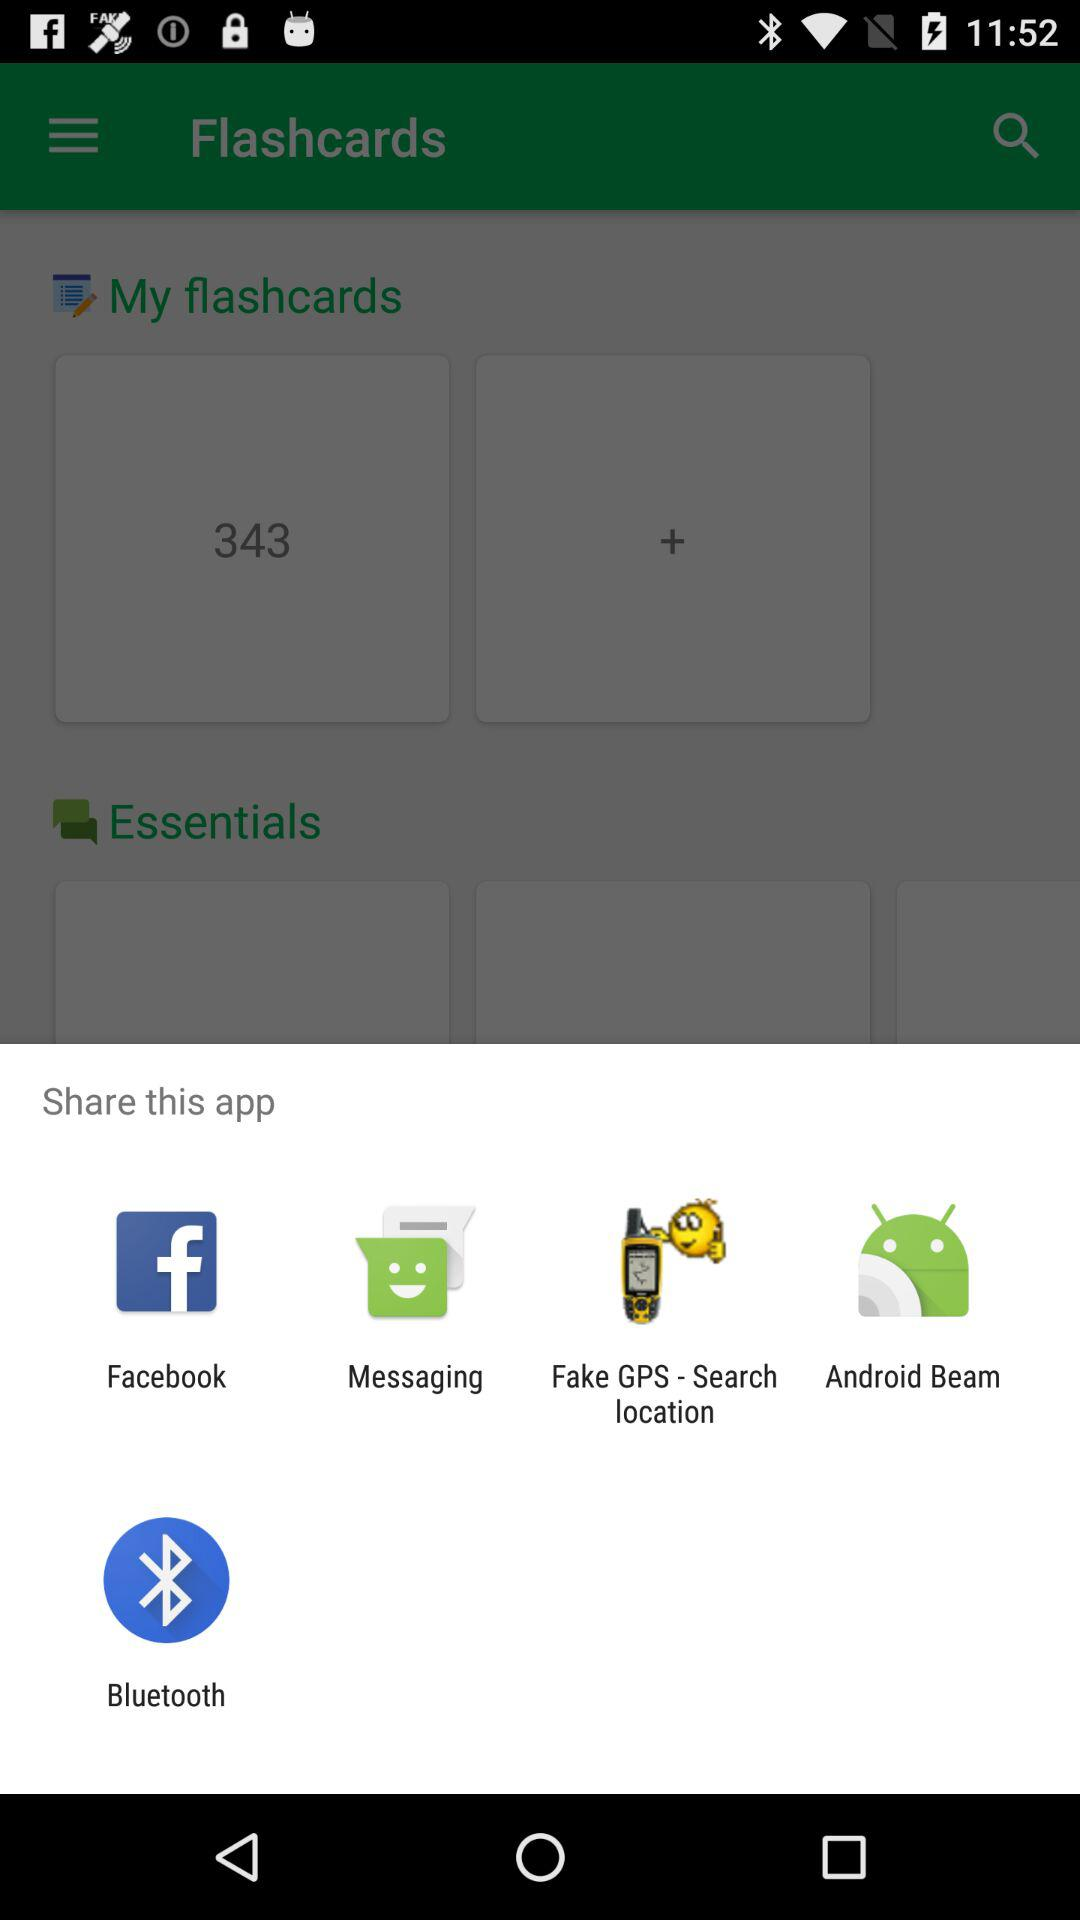How many flashcards are there in "My flashcards"? There are 343 flashcards in "My flashcards". 